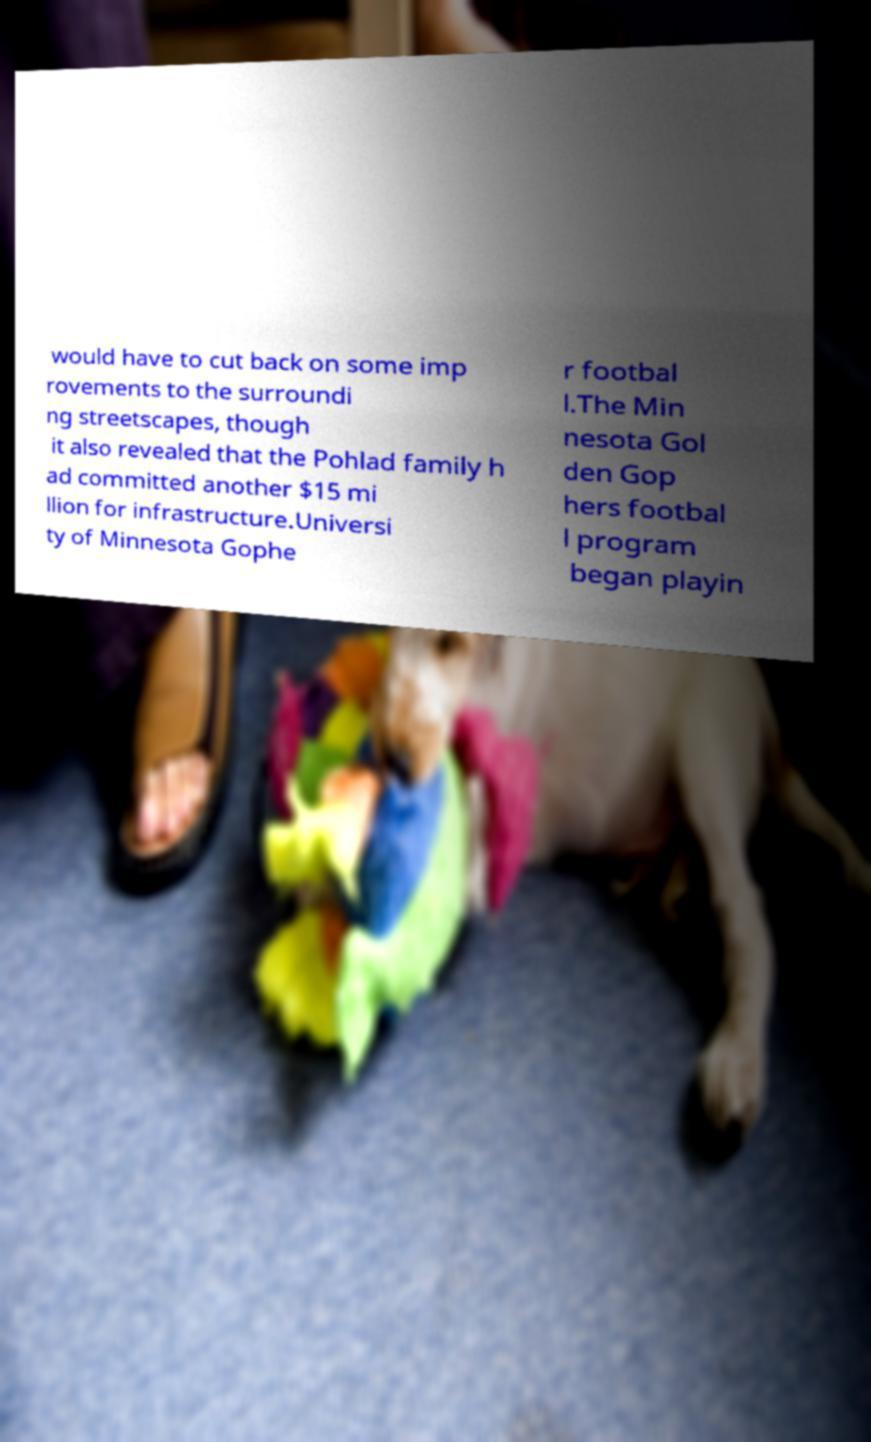There's text embedded in this image that I need extracted. Can you transcribe it verbatim? would have to cut back on some imp rovements to the surroundi ng streetscapes, though it also revealed that the Pohlad family h ad committed another $15 mi llion for infrastructure.Universi ty of Minnesota Gophe r footbal l.The Min nesota Gol den Gop hers footbal l program began playin 